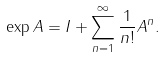<formula> <loc_0><loc_0><loc_500><loc_500>\exp { A } = I + \sum _ { n = 1 } ^ { \infty } { \frac { 1 } { n ! } A ^ { n } } .</formula> 